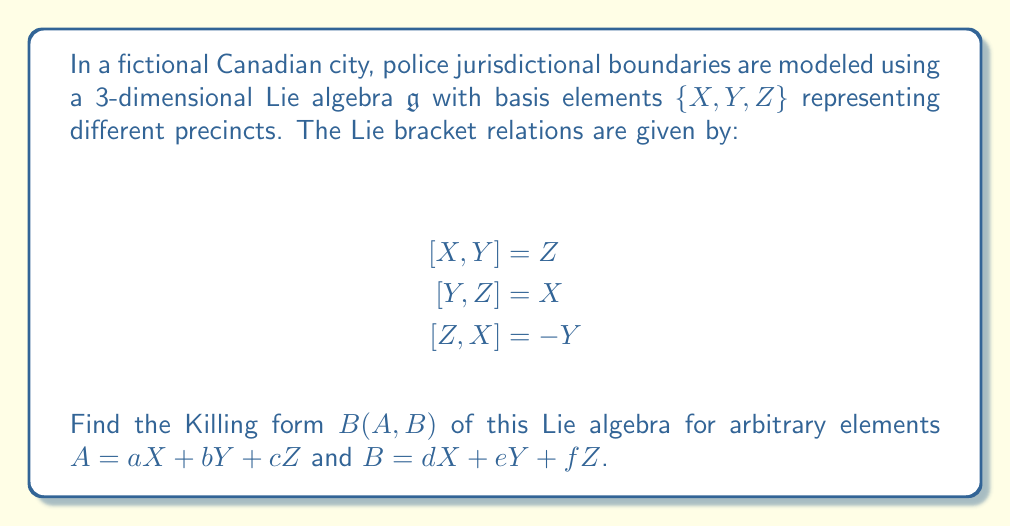Solve this math problem. To find the Killing form of the given Lie algebra, we follow these steps:

1) The Killing form is defined as $B(A,B) = \text{tr}(\text{ad}_A \circ \text{ad}_B)$, where $\text{ad}_A$ is the adjoint representation of $A$.

2) First, we need to find the matrix representations of $\text{ad}_X$, $\text{ad}_Y$, and $\text{ad}_Z$:

   $\text{ad}_X = \begin{pmatrix} 0 & 0 & 1 \\ 0 & 0 & -1 \\ -1 & 0 & 0 \end{pmatrix}$

   $\text{ad}_Y = \begin{pmatrix} 0 & 0 & 1 \\ 0 & 0 & 0 \\ 0 & -1 & 0 \end{pmatrix}$

   $\text{ad}_Z = \begin{pmatrix} 0 & -1 & 0 \\ 1 & 0 & 0 \\ 0 & 0 & 0 \end{pmatrix}$

3) For arbitrary elements $A = aX + bY + cZ$ and $B = dX + eY + fZ$, we have:

   $\text{ad}_A = a\text{ad}_X + b\text{ad}_Y + c\text{ad}_Z$
   $\text{ad}_B = d\text{ad}_X + e\text{ad}_Y + f\text{ad}_Z$

4) Multiplying these matrices and taking the trace:

   $\text{tr}(\text{ad}_A \circ \text{ad}_B) = \text{tr}((a\text{ad}_X + b\text{ad}_Y + c\text{ad}_Z)(d\text{ad}_X + e\text{ad}_Y + f\text{ad}_Z))$

5) Expanding and simplifying, we get:

   $B(A,B) = -2(ad + be + cf)$

This is the Killing form for the given Lie algebra.
Answer: The Killing form of the given Lie algebra for arbitrary elements $A = aX + bY + cZ$ and $B = dX + eY + fZ$ is:

$$B(A,B) = -2(ad + be + cf)$$ 